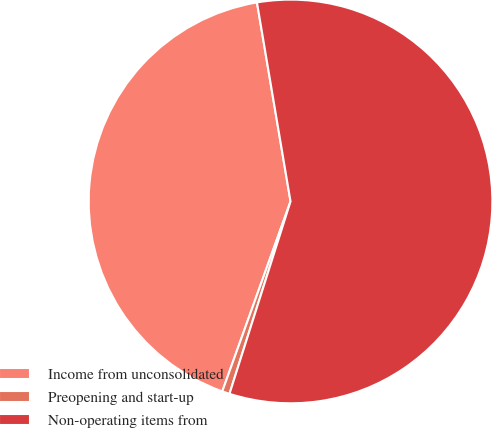Convert chart. <chart><loc_0><loc_0><loc_500><loc_500><pie_chart><fcel>Income from unconsolidated<fcel>Preopening and start-up<fcel>Non-operating items from<nl><fcel>41.85%<fcel>0.6%<fcel>57.55%<nl></chart> 